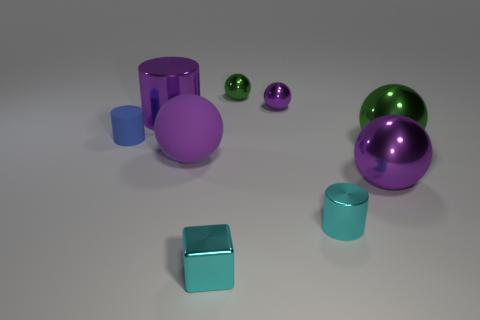What is the size of the matte sphere that is the same color as the large cylinder?
Provide a succinct answer. Large. What number of things are either purple things that are to the left of the small purple shiny sphere or purple things in front of the small blue rubber object?
Ensure brevity in your answer.  3. Are there more cyan cubes that are to the right of the small cyan block than green objects that are behind the small blue object?
Your answer should be compact. No. What is the material of the cylinder right of the metal cylinder that is behind the cyan metal object that is behind the tiny cyan metal cube?
Ensure brevity in your answer.  Metal. Does the large purple object to the right of the cube have the same shape as the cyan thing on the right side of the cube?
Your answer should be very brief. No. Are there any purple rubber balls that have the same size as the blue cylinder?
Your answer should be compact. No. How many purple objects are small matte things or big matte balls?
Give a very brief answer. 1. What number of big spheres are the same color as the tiny rubber cylinder?
Give a very brief answer. 0. What number of blocks are either metallic objects or tiny rubber things?
Your answer should be compact. 1. The cylinder right of the big metal cylinder is what color?
Your response must be concise. Cyan. 